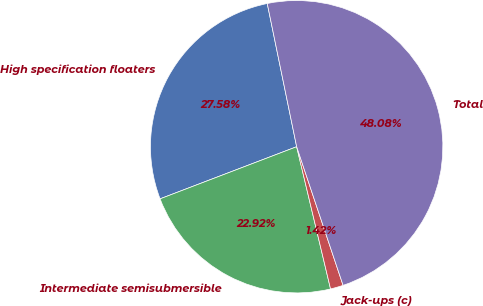<chart> <loc_0><loc_0><loc_500><loc_500><pie_chart><fcel>High specification floaters<fcel>Intermediate semisubmersible<fcel>Jack-ups (c)<fcel>Total<nl><fcel>27.58%<fcel>22.92%<fcel>1.42%<fcel>48.08%<nl></chart> 